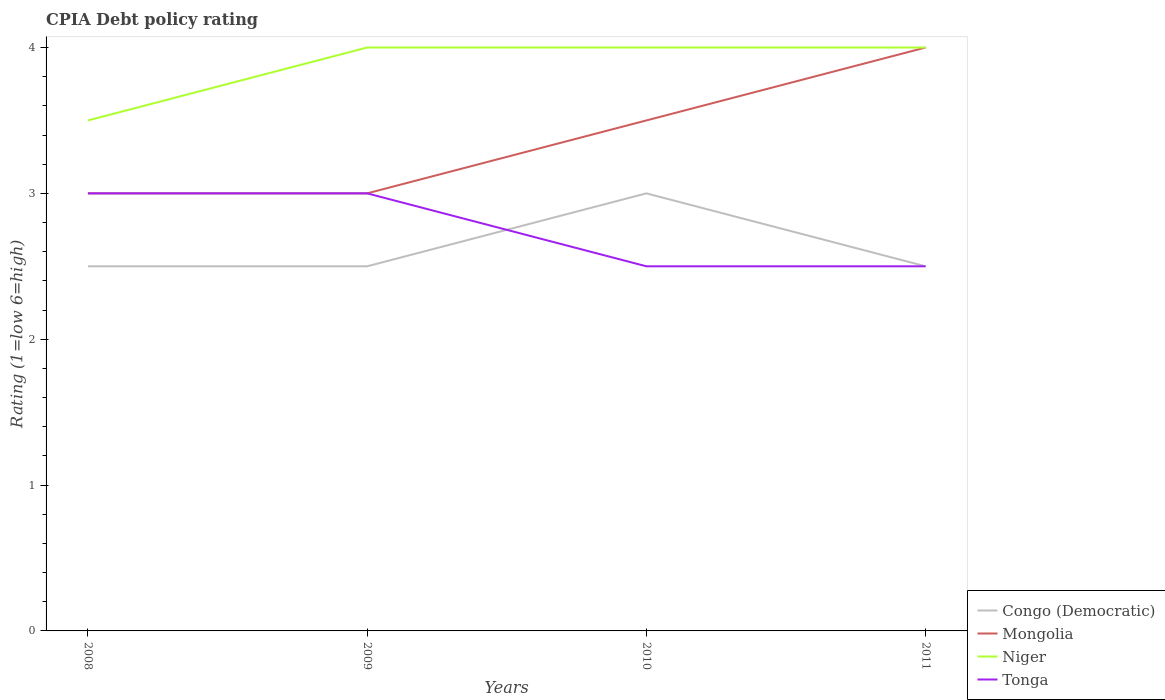Across all years, what is the maximum CPIA rating in Mongolia?
Your answer should be very brief. 3. In which year was the CPIA rating in Congo (Democratic) maximum?
Your answer should be compact. 2008. What is the total CPIA rating in Niger in the graph?
Keep it short and to the point. 0. What is the difference between the highest and the second highest CPIA rating in Mongolia?
Your answer should be very brief. 1. What is the difference between the highest and the lowest CPIA rating in Congo (Democratic)?
Provide a short and direct response. 1. Is the CPIA rating in Niger strictly greater than the CPIA rating in Mongolia over the years?
Offer a very short reply. No. What is the difference between two consecutive major ticks on the Y-axis?
Provide a short and direct response. 1. Does the graph contain any zero values?
Ensure brevity in your answer.  No. How many legend labels are there?
Your response must be concise. 4. How are the legend labels stacked?
Provide a succinct answer. Vertical. What is the title of the graph?
Make the answer very short. CPIA Debt policy rating. Does "Aruba" appear as one of the legend labels in the graph?
Your answer should be compact. No. What is the label or title of the X-axis?
Give a very brief answer. Years. What is the label or title of the Y-axis?
Offer a terse response. Rating (1=low 6=high). What is the Rating (1=low 6=high) of Congo (Democratic) in 2008?
Offer a very short reply. 2.5. What is the Rating (1=low 6=high) of Niger in 2008?
Your response must be concise. 3.5. What is the Rating (1=low 6=high) of Niger in 2009?
Offer a terse response. 4. What is the Rating (1=low 6=high) in Mongolia in 2010?
Keep it short and to the point. 3.5. What is the Rating (1=low 6=high) of Niger in 2010?
Your response must be concise. 4. What is the Rating (1=low 6=high) of Tonga in 2010?
Your response must be concise. 2.5. What is the Rating (1=low 6=high) in Niger in 2011?
Offer a very short reply. 4. Across all years, what is the maximum Rating (1=low 6=high) of Congo (Democratic)?
Your answer should be compact. 3. Across all years, what is the maximum Rating (1=low 6=high) of Niger?
Ensure brevity in your answer.  4. Across all years, what is the maximum Rating (1=low 6=high) in Tonga?
Your answer should be very brief. 3. Across all years, what is the minimum Rating (1=low 6=high) in Mongolia?
Your answer should be very brief. 3. Across all years, what is the minimum Rating (1=low 6=high) of Niger?
Provide a short and direct response. 3.5. Across all years, what is the minimum Rating (1=low 6=high) of Tonga?
Ensure brevity in your answer.  2.5. What is the total Rating (1=low 6=high) in Congo (Democratic) in the graph?
Your answer should be very brief. 10.5. What is the total Rating (1=low 6=high) in Tonga in the graph?
Your response must be concise. 11. What is the difference between the Rating (1=low 6=high) of Congo (Democratic) in 2008 and that in 2009?
Your answer should be compact. 0. What is the difference between the Rating (1=low 6=high) in Niger in 2008 and that in 2009?
Provide a succinct answer. -0.5. What is the difference between the Rating (1=low 6=high) of Congo (Democratic) in 2008 and that in 2010?
Ensure brevity in your answer.  -0.5. What is the difference between the Rating (1=low 6=high) in Mongolia in 2008 and that in 2011?
Offer a very short reply. -1. What is the difference between the Rating (1=low 6=high) of Mongolia in 2009 and that in 2010?
Ensure brevity in your answer.  -0.5. What is the difference between the Rating (1=low 6=high) in Niger in 2009 and that in 2010?
Your answer should be very brief. 0. What is the difference between the Rating (1=low 6=high) of Tonga in 2009 and that in 2010?
Make the answer very short. 0.5. What is the difference between the Rating (1=low 6=high) in Congo (Democratic) in 2009 and that in 2011?
Make the answer very short. 0. What is the difference between the Rating (1=low 6=high) of Mongolia in 2009 and that in 2011?
Provide a short and direct response. -1. What is the difference between the Rating (1=low 6=high) in Niger in 2009 and that in 2011?
Provide a short and direct response. 0. What is the difference between the Rating (1=low 6=high) of Mongolia in 2010 and that in 2011?
Keep it short and to the point. -0.5. What is the difference between the Rating (1=low 6=high) of Niger in 2010 and that in 2011?
Offer a very short reply. 0. What is the difference between the Rating (1=low 6=high) in Congo (Democratic) in 2008 and the Rating (1=low 6=high) in Mongolia in 2009?
Provide a short and direct response. -0.5. What is the difference between the Rating (1=low 6=high) of Congo (Democratic) in 2008 and the Rating (1=low 6=high) of Niger in 2009?
Provide a short and direct response. -1.5. What is the difference between the Rating (1=low 6=high) of Mongolia in 2008 and the Rating (1=low 6=high) of Niger in 2009?
Keep it short and to the point. -1. What is the difference between the Rating (1=low 6=high) in Niger in 2008 and the Rating (1=low 6=high) in Tonga in 2009?
Give a very brief answer. 0.5. What is the difference between the Rating (1=low 6=high) of Congo (Democratic) in 2008 and the Rating (1=low 6=high) of Mongolia in 2010?
Your answer should be very brief. -1. What is the difference between the Rating (1=low 6=high) of Congo (Democratic) in 2008 and the Rating (1=low 6=high) of Tonga in 2010?
Your answer should be very brief. 0. What is the difference between the Rating (1=low 6=high) in Mongolia in 2008 and the Rating (1=low 6=high) in Niger in 2010?
Ensure brevity in your answer.  -1. What is the difference between the Rating (1=low 6=high) of Niger in 2008 and the Rating (1=low 6=high) of Tonga in 2010?
Provide a short and direct response. 1. What is the difference between the Rating (1=low 6=high) of Congo (Democratic) in 2008 and the Rating (1=low 6=high) of Mongolia in 2011?
Offer a terse response. -1.5. What is the difference between the Rating (1=low 6=high) in Mongolia in 2008 and the Rating (1=low 6=high) in Niger in 2011?
Ensure brevity in your answer.  -1. What is the difference between the Rating (1=low 6=high) in Mongolia in 2008 and the Rating (1=low 6=high) in Tonga in 2011?
Make the answer very short. 0.5. What is the difference between the Rating (1=low 6=high) of Congo (Democratic) in 2009 and the Rating (1=low 6=high) of Mongolia in 2010?
Ensure brevity in your answer.  -1. What is the difference between the Rating (1=low 6=high) in Congo (Democratic) in 2009 and the Rating (1=low 6=high) in Niger in 2010?
Keep it short and to the point. -1.5. What is the difference between the Rating (1=low 6=high) of Mongolia in 2009 and the Rating (1=low 6=high) of Tonga in 2010?
Offer a terse response. 0.5. What is the difference between the Rating (1=low 6=high) of Niger in 2009 and the Rating (1=low 6=high) of Tonga in 2010?
Keep it short and to the point. 1.5. What is the difference between the Rating (1=low 6=high) of Congo (Democratic) in 2009 and the Rating (1=low 6=high) of Mongolia in 2011?
Offer a very short reply. -1.5. What is the difference between the Rating (1=low 6=high) of Congo (Democratic) in 2009 and the Rating (1=low 6=high) of Tonga in 2011?
Provide a succinct answer. 0. What is the difference between the Rating (1=low 6=high) of Niger in 2009 and the Rating (1=low 6=high) of Tonga in 2011?
Provide a succinct answer. 1.5. What is the difference between the Rating (1=low 6=high) in Congo (Democratic) in 2010 and the Rating (1=low 6=high) in Tonga in 2011?
Make the answer very short. 0.5. What is the difference between the Rating (1=low 6=high) of Niger in 2010 and the Rating (1=low 6=high) of Tonga in 2011?
Your answer should be very brief. 1.5. What is the average Rating (1=low 6=high) in Congo (Democratic) per year?
Keep it short and to the point. 2.62. What is the average Rating (1=low 6=high) in Mongolia per year?
Make the answer very short. 3.38. What is the average Rating (1=low 6=high) in Niger per year?
Provide a succinct answer. 3.88. What is the average Rating (1=low 6=high) of Tonga per year?
Offer a terse response. 2.75. In the year 2008, what is the difference between the Rating (1=low 6=high) of Congo (Democratic) and Rating (1=low 6=high) of Niger?
Give a very brief answer. -1. In the year 2008, what is the difference between the Rating (1=low 6=high) in Congo (Democratic) and Rating (1=low 6=high) in Tonga?
Your response must be concise. -0.5. In the year 2008, what is the difference between the Rating (1=low 6=high) in Mongolia and Rating (1=low 6=high) in Niger?
Give a very brief answer. -0.5. In the year 2008, what is the difference between the Rating (1=low 6=high) of Mongolia and Rating (1=low 6=high) of Tonga?
Your answer should be compact. 0. In the year 2009, what is the difference between the Rating (1=low 6=high) of Congo (Democratic) and Rating (1=low 6=high) of Niger?
Your answer should be compact. -1.5. In the year 2010, what is the difference between the Rating (1=low 6=high) of Congo (Democratic) and Rating (1=low 6=high) of Tonga?
Provide a short and direct response. 0.5. In the year 2010, what is the difference between the Rating (1=low 6=high) in Mongolia and Rating (1=low 6=high) in Niger?
Your answer should be compact. -0.5. In the year 2010, what is the difference between the Rating (1=low 6=high) in Niger and Rating (1=low 6=high) in Tonga?
Your answer should be very brief. 1.5. In the year 2011, what is the difference between the Rating (1=low 6=high) in Congo (Democratic) and Rating (1=low 6=high) in Tonga?
Ensure brevity in your answer.  0. In the year 2011, what is the difference between the Rating (1=low 6=high) in Mongolia and Rating (1=low 6=high) in Niger?
Offer a terse response. 0. What is the ratio of the Rating (1=low 6=high) of Mongolia in 2008 to that in 2009?
Make the answer very short. 1. What is the ratio of the Rating (1=low 6=high) of Niger in 2008 to that in 2009?
Your answer should be compact. 0.88. What is the ratio of the Rating (1=low 6=high) of Congo (Democratic) in 2008 to that in 2010?
Make the answer very short. 0.83. What is the ratio of the Rating (1=low 6=high) in Mongolia in 2008 to that in 2010?
Your answer should be compact. 0.86. What is the ratio of the Rating (1=low 6=high) in Niger in 2008 to that in 2011?
Keep it short and to the point. 0.88. What is the ratio of the Rating (1=low 6=high) of Mongolia in 2009 to that in 2010?
Offer a terse response. 0.86. What is the ratio of the Rating (1=low 6=high) in Congo (Democratic) in 2009 to that in 2011?
Keep it short and to the point. 1. What is the ratio of the Rating (1=low 6=high) of Mongolia in 2009 to that in 2011?
Provide a short and direct response. 0.75. What is the ratio of the Rating (1=low 6=high) of Niger in 2009 to that in 2011?
Offer a terse response. 1. What is the ratio of the Rating (1=low 6=high) in Congo (Democratic) in 2010 to that in 2011?
Offer a terse response. 1.2. What is the ratio of the Rating (1=low 6=high) in Niger in 2010 to that in 2011?
Offer a terse response. 1. What is the ratio of the Rating (1=low 6=high) of Tonga in 2010 to that in 2011?
Make the answer very short. 1. What is the difference between the highest and the lowest Rating (1=low 6=high) in Niger?
Offer a terse response. 0.5. What is the difference between the highest and the lowest Rating (1=low 6=high) in Tonga?
Make the answer very short. 0.5. 